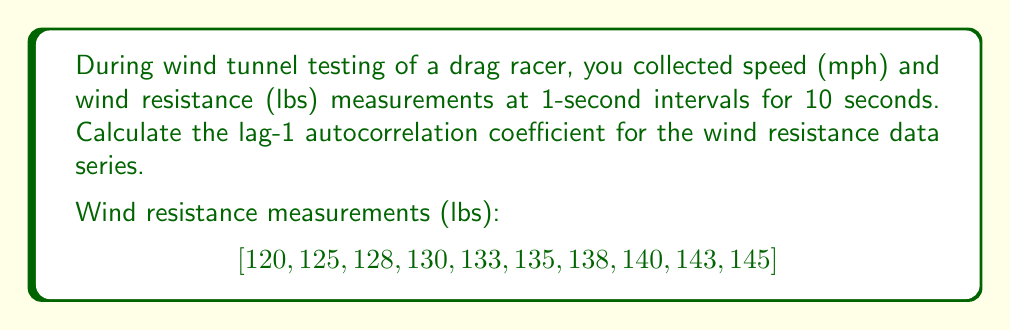Give your solution to this math problem. To calculate the lag-1 autocorrelation coefficient for the wind resistance data series, we'll follow these steps:

1. Calculate the mean of the series:
   $$\bar{x} = \frac{1}{n}\sum_{i=1}^n x_i = \frac{120 + 125 + 128 + 130 + 133 + 135 + 138 + 140 + 143 + 145}{10} = 133.7$$

2. Calculate the variance of the series:
   $$s^2 = \frac{1}{n-1}\sum_{i=1}^n (x_i - \bar{x})^2$$
   
   $$s^2 = \frac{1}{9}[(120-133.7)^2 + (125-133.7)^2 + ... + (145-133.7)^2] = 66.68$$

3. Calculate the autocovariance at lag 1:
   $$c_1 = \frac{1}{n-1}\sum_{i=1}^{n-1} (x_i - \bar{x})(x_{i+1} - \bar{x})$$
   
   $$c_1 = \frac{1}{9}[(120-133.7)(125-133.7) + (125-133.7)(128-133.7) + ... + (143-133.7)(145-133.7)]$$
   
   $$c_1 = 63.61$$

4. Calculate the lag-1 autocorrelation coefficient:
   $$r_1 = \frac{c_1}{s^2} = \frac{63.61}{66.68} = 0.954$$

The lag-1 autocorrelation coefficient is 0.954, indicating a strong positive autocorrelation between consecutive wind resistance measurements.
Answer: The lag-1 autocorrelation coefficient for the wind resistance data series is 0.954. 